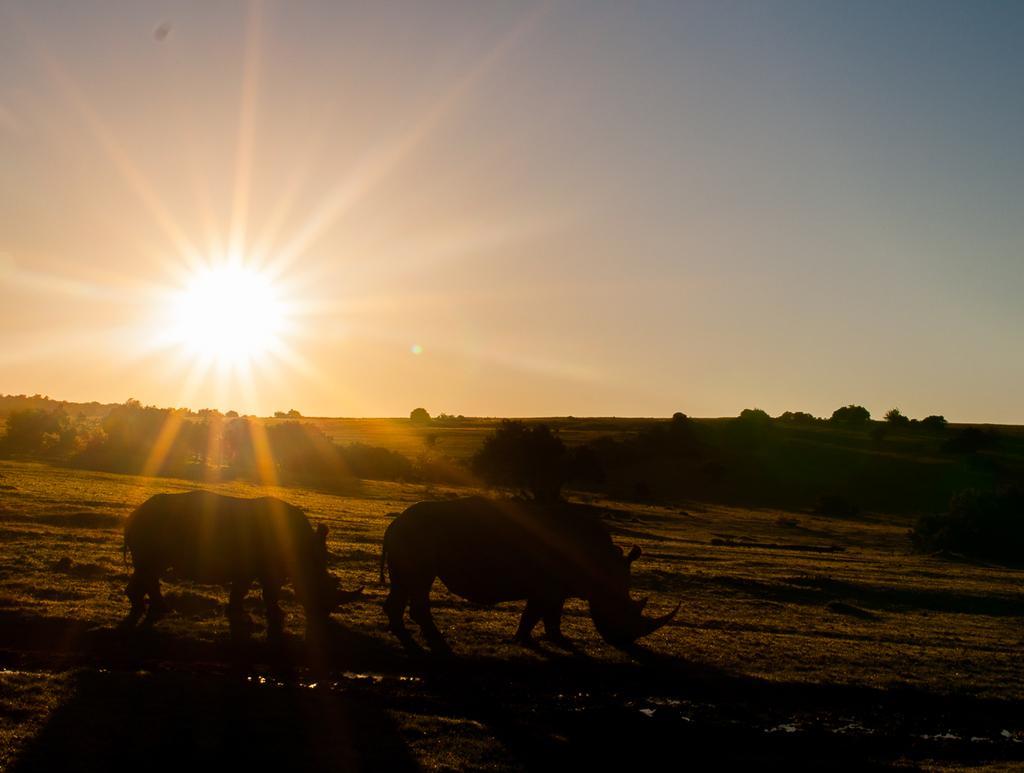Please provide a concise description of this image. In this picture we can see animals on the ground and in the background we can see trees,sky. 